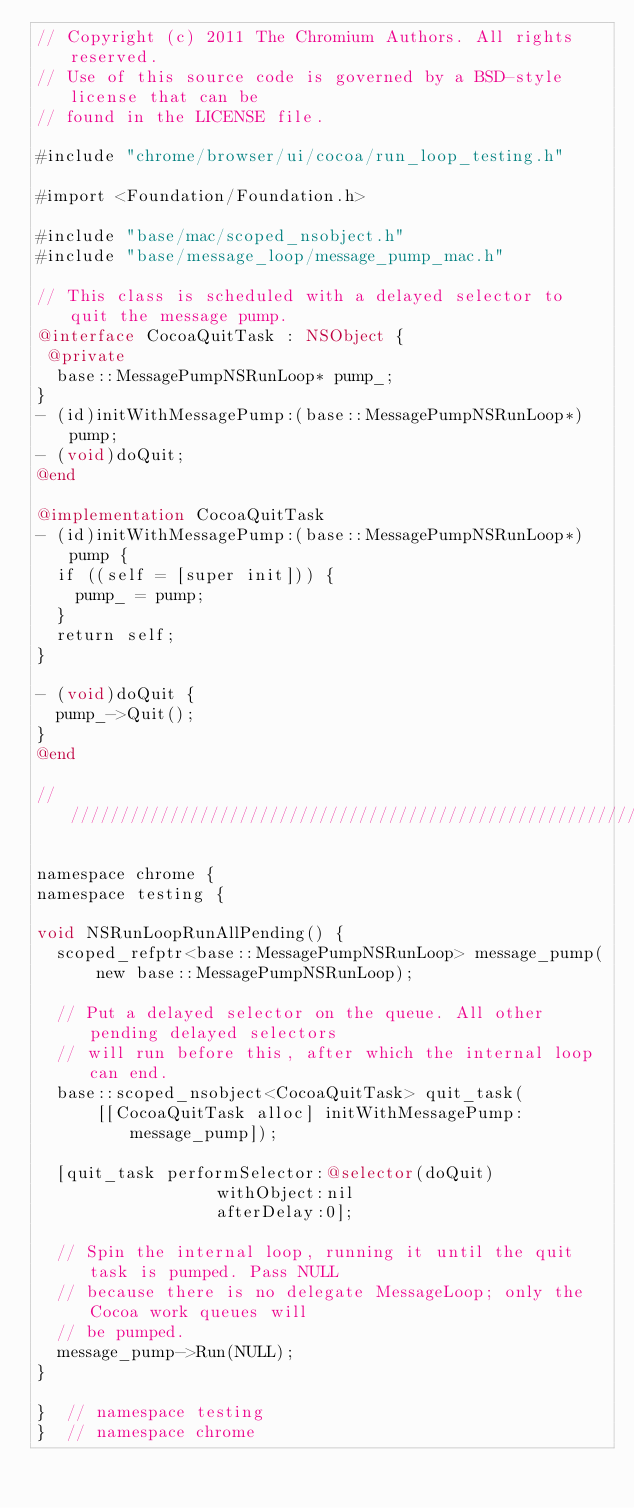<code> <loc_0><loc_0><loc_500><loc_500><_ObjectiveC_>// Copyright (c) 2011 The Chromium Authors. All rights reserved.
// Use of this source code is governed by a BSD-style license that can be
// found in the LICENSE file.

#include "chrome/browser/ui/cocoa/run_loop_testing.h"

#import <Foundation/Foundation.h>

#include "base/mac/scoped_nsobject.h"
#include "base/message_loop/message_pump_mac.h"

// This class is scheduled with a delayed selector to quit the message pump.
@interface CocoaQuitTask : NSObject {
 @private
  base::MessagePumpNSRunLoop* pump_;
}
- (id)initWithMessagePump:(base::MessagePumpNSRunLoop*)pump;
- (void)doQuit;
@end

@implementation CocoaQuitTask
- (id)initWithMessagePump:(base::MessagePumpNSRunLoop*)pump {
  if ((self = [super init])) {
    pump_ = pump;
  }
  return self;
}

- (void)doQuit {
  pump_->Quit();
}
@end

////////////////////////////////////////////////////////////////////////////////

namespace chrome {
namespace testing {

void NSRunLoopRunAllPending() {
  scoped_refptr<base::MessagePumpNSRunLoop> message_pump(
      new base::MessagePumpNSRunLoop);

  // Put a delayed selector on the queue. All other pending delayed selectors
  // will run before this, after which the internal loop can end.
  base::scoped_nsobject<CocoaQuitTask> quit_task(
      [[CocoaQuitTask alloc] initWithMessagePump:message_pump]);

  [quit_task performSelector:@selector(doQuit)
                  withObject:nil
                  afterDelay:0];

  // Spin the internal loop, running it until the quit task is pumped. Pass NULL
  // because there is no delegate MessageLoop; only the Cocoa work queues will
  // be pumped.
  message_pump->Run(NULL);
}

}  // namespace testing
}  // namespace chrome
</code> 